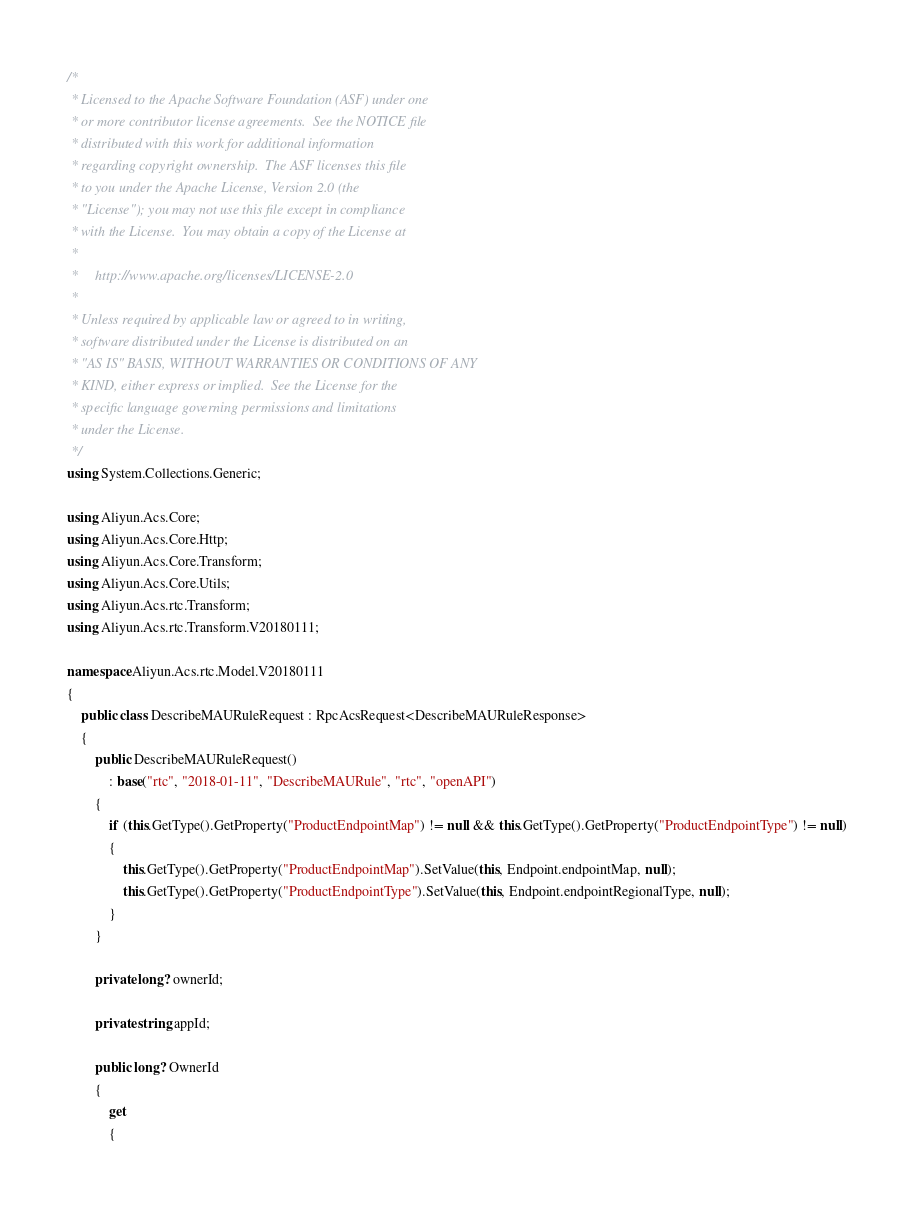<code> <loc_0><loc_0><loc_500><loc_500><_C#_>/*
 * Licensed to the Apache Software Foundation (ASF) under one
 * or more contributor license agreements.  See the NOTICE file
 * distributed with this work for additional information
 * regarding copyright ownership.  The ASF licenses this file
 * to you under the Apache License, Version 2.0 (the
 * "License"); you may not use this file except in compliance
 * with the License.  You may obtain a copy of the License at
 *
 *     http://www.apache.org/licenses/LICENSE-2.0
 *
 * Unless required by applicable law or agreed to in writing,
 * software distributed under the License is distributed on an
 * "AS IS" BASIS, WITHOUT WARRANTIES OR CONDITIONS OF ANY
 * KIND, either express or implied.  See the License for the
 * specific language governing permissions and limitations
 * under the License.
 */
using System.Collections.Generic;

using Aliyun.Acs.Core;
using Aliyun.Acs.Core.Http;
using Aliyun.Acs.Core.Transform;
using Aliyun.Acs.Core.Utils;
using Aliyun.Acs.rtc.Transform;
using Aliyun.Acs.rtc.Transform.V20180111;

namespace Aliyun.Acs.rtc.Model.V20180111
{
    public class DescribeMAURuleRequest : RpcAcsRequest<DescribeMAURuleResponse>
    {
        public DescribeMAURuleRequest()
            : base("rtc", "2018-01-11", "DescribeMAURule", "rtc", "openAPI")
        {
            if (this.GetType().GetProperty("ProductEndpointMap") != null && this.GetType().GetProperty("ProductEndpointType") != null)
            {
                this.GetType().GetProperty("ProductEndpointMap").SetValue(this, Endpoint.endpointMap, null);
                this.GetType().GetProperty("ProductEndpointType").SetValue(this, Endpoint.endpointRegionalType, null);
            }
        }

		private long? ownerId;

		private string appId;

		public long? OwnerId
		{
			get
			{</code> 